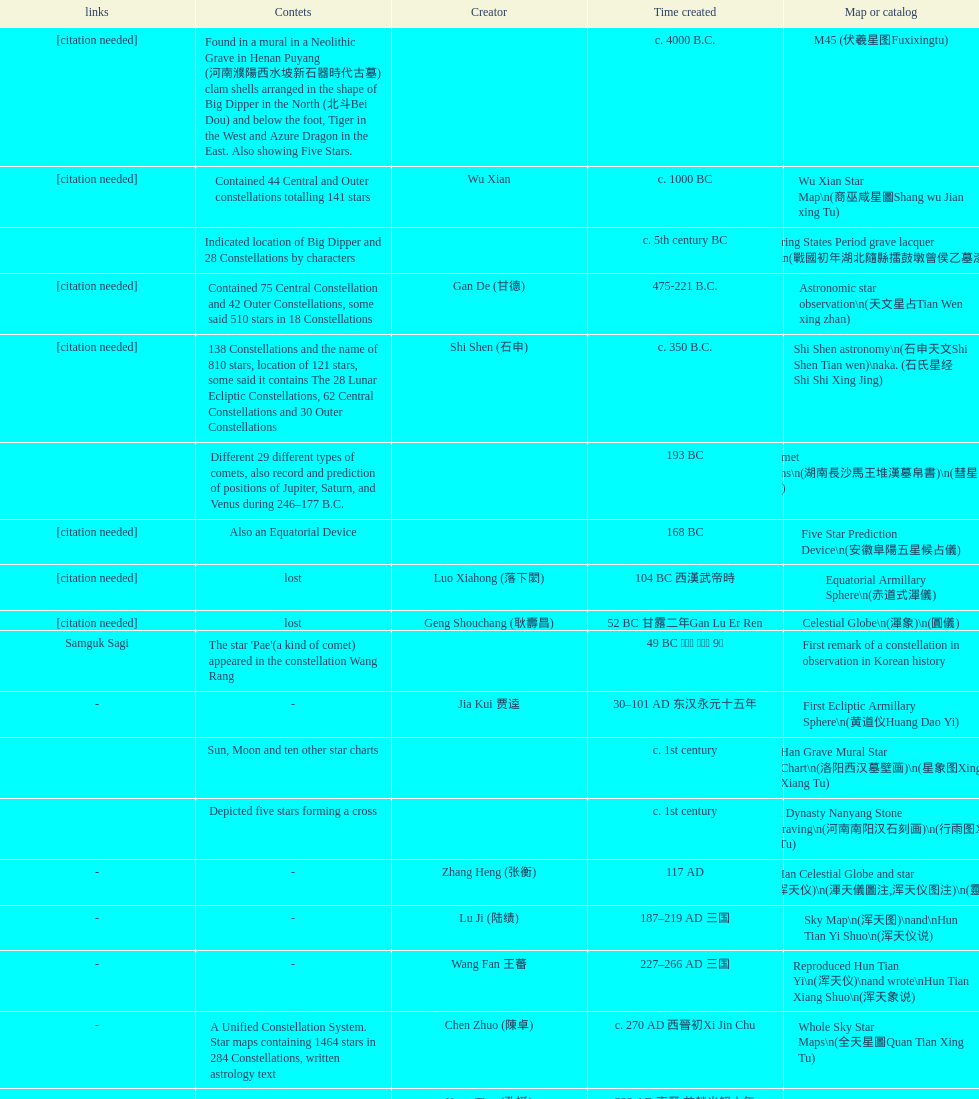Which map or catalog was created last? Sky in Google Earth KML. 